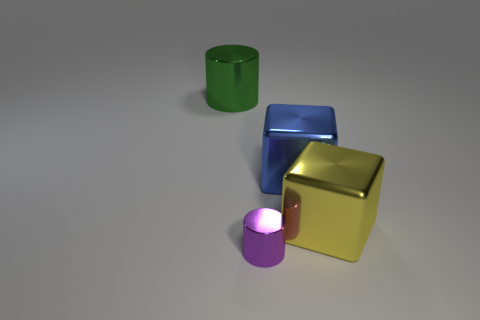There is a cylinder that is to the right of the big object to the left of the metal cylinder that is in front of the big yellow block; what is its color?
Provide a short and direct response. Purple. Is the shape of the tiny object the same as the big green metal thing?
Your response must be concise. Yes. Are there the same number of metal cylinders that are in front of the green thing and tiny brown balls?
Offer a very short reply. No. How many other things are there of the same material as the tiny cylinder?
Make the answer very short. 3. Does the block that is behind the yellow thing have the same size as the metal cylinder in front of the large green metal object?
Your answer should be compact. No. How many objects are large cubes that are on the left side of the yellow metal object or objects on the right side of the large green metal object?
Give a very brief answer. 3. How many shiny things are either blue objects or yellow cubes?
Keep it short and to the point. 2. Is there anything else that has the same size as the purple cylinder?
Make the answer very short. No. What is the shape of the tiny purple metal thing to the left of the big block behind the yellow object?
Offer a very short reply. Cylinder. What number of small purple shiny cylinders are on the left side of the cylinder behind the small purple object?
Make the answer very short. 0. 